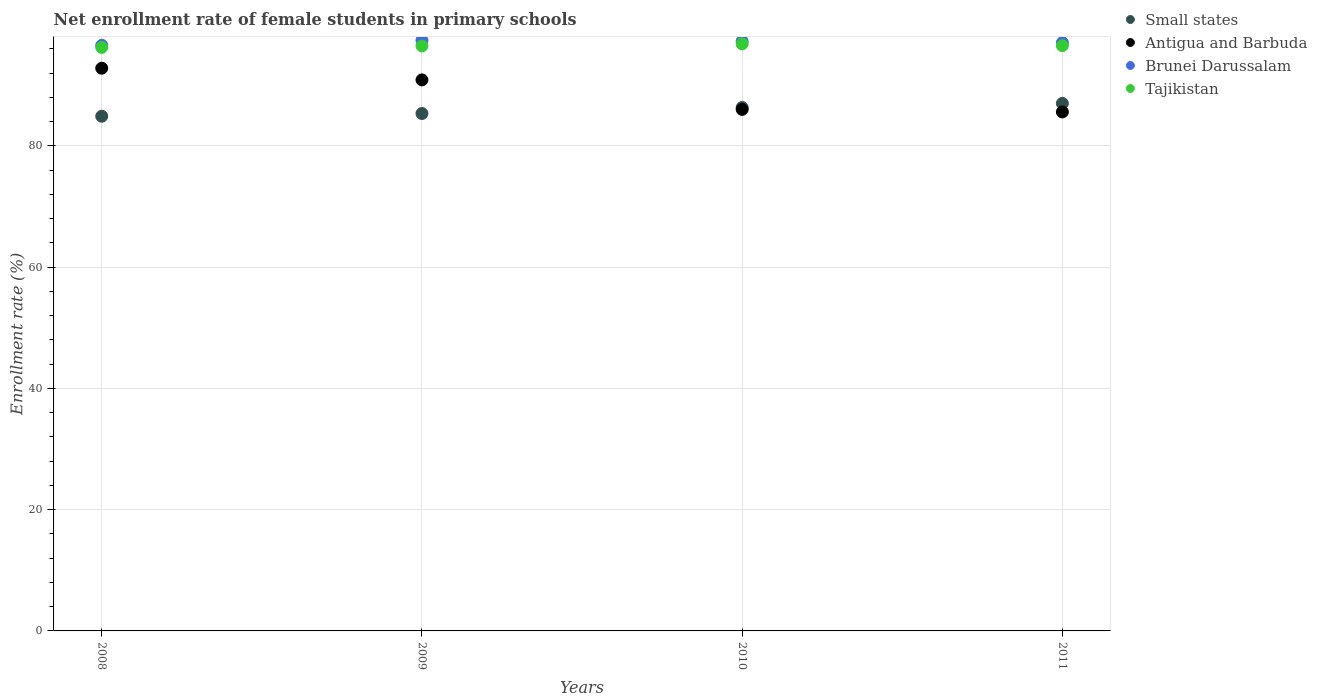How many different coloured dotlines are there?
Your answer should be compact. 4. Is the number of dotlines equal to the number of legend labels?
Offer a very short reply. Yes. What is the net enrollment rate of female students in primary schools in Brunei Darussalam in 2010?
Keep it short and to the point. 97.24. Across all years, what is the maximum net enrollment rate of female students in primary schools in Antigua and Barbuda?
Provide a succinct answer. 92.81. Across all years, what is the minimum net enrollment rate of female students in primary schools in Brunei Darussalam?
Your answer should be compact. 96.58. In which year was the net enrollment rate of female students in primary schools in Small states minimum?
Your answer should be compact. 2008. What is the total net enrollment rate of female students in primary schools in Small states in the graph?
Your answer should be very brief. 343.55. What is the difference between the net enrollment rate of female students in primary schools in Small states in 2009 and that in 2011?
Offer a very short reply. -1.67. What is the difference between the net enrollment rate of female students in primary schools in Brunei Darussalam in 2011 and the net enrollment rate of female students in primary schools in Antigua and Barbuda in 2010?
Ensure brevity in your answer.  11.01. What is the average net enrollment rate of female students in primary schools in Tajikistan per year?
Provide a succinct answer. 96.51. In the year 2008, what is the difference between the net enrollment rate of female students in primary schools in Brunei Darussalam and net enrollment rate of female students in primary schools in Tajikistan?
Your answer should be compact. 0.34. In how many years, is the net enrollment rate of female students in primary schools in Brunei Darussalam greater than 12 %?
Make the answer very short. 4. What is the ratio of the net enrollment rate of female students in primary schools in Brunei Darussalam in 2008 to that in 2011?
Offer a terse response. 1. What is the difference between the highest and the second highest net enrollment rate of female students in primary schools in Antigua and Barbuda?
Provide a short and direct response. 1.93. What is the difference between the highest and the lowest net enrollment rate of female students in primary schools in Brunei Darussalam?
Offer a terse response. 0.82. In how many years, is the net enrollment rate of female students in primary schools in Brunei Darussalam greater than the average net enrollment rate of female students in primary schools in Brunei Darussalam taken over all years?
Keep it short and to the point. 2. Is the sum of the net enrollment rate of female students in primary schools in Tajikistan in 2010 and 2011 greater than the maximum net enrollment rate of female students in primary schools in Brunei Darussalam across all years?
Your answer should be very brief. Yes. Is it the case that in every year, the sum of the net enrollment rate of female students in primary schools in Small states and net enrollment rate of female students in primary schools in Tajikistan  is greater than the sum of net enrollment rate of female students in primary schools in Brunei Darussalam and net enrollment rate of female students in primary schools in Antigua and Barbuda?
Ensure brevity in your answer.  No. Is the net enrollment rate of female students in primary schools in Small states strictly greater than the net enrollment rate of female students in primary schools in Brunei Darussalam over the years?
Your answer should be compact. No. How many dotlines are there?
Your answer should be compact. 4. How many years are there in the graph?
Keep it short and to the point. 4. What is the difference between two consecutive major ticks on the Y-axis?
Provide a short and direct response. 20. Does the graph contain any zero values?
Provide a succinct answer. No. What is the title of the graph?
Your answer should be compact. Net enrollment rate of female students in primary schools. Does "Venezuela" appear as one of the legend labels in the graph?
Make the answer very short. No. What is the label or title of the X-axis?
Keep it short and to the point. Years. What is the label or title of the Y-axis?
Your response must be concise. Enrollment rate (%). What is the Enrollment rate (%) in Small states in 2008?
Your answer should be very brief. 84.89. What is the Enrollment rate (%) in Antigua and Barbuda in 2008?
Keep it short and to the point. 92.81. What is the Enrollment rate (%) of Brunei Darussalam in 2008?
Your answer should be very brief. 96.58. What is the Enrollment rate (%) of Tajikistan in 2008?
Provide a succinct answer. 96.24. What is the Enrollment rate (%) of Small states in 2009?
Ensure brevity in your answer.  85.34. What is the Enrollment rate (%) in Antigua and Barbuda in 2009?
Provide a short and direct response. 90.88. What is the Enrollment rate (%) of Brunei Darussalam in 2009?
Offer a very short reply. 97.4. What is the Enrollment rate (%) of Tajikistan in 2009?
Provide a succinct answer. 96.47. What is the Enrollment rate (%) in Small states in 2010?
Ensure brevity in your answer.  86.33. What is the Enrollment rate (%) of Antigua and Barbuda in 2010?
Ensure brevity in your answer.  86.01. What is the Enrollment rate (%) of Brunei Darussalam in 2010?
Offer a terse response. 97.24. What is the Enrollment rate (%) of Tajikistan in 2010?
Offer a very short reply. 96.82. What is the Enrollment rate (%) in Small states in 2011?
Your answer should be very brief. 87. What is the Enrollment rate (%) in Antigua and Barbuda in 2011?
Your answer should be very brief. 85.59. What is the Enrollment rate (%) in Brunei Darussalam in 2011?
Ensure brevity in your answer.  97.02. What is the Enrollment rate (%) in Tajikistan in 2011?
Keep it short and to the point. 96.52. Across all years, what is the maximum Enrollment rate (%) of Small states?
Your response must be concise. 87. Across all years, what is the maximum Enrollment rate (%) in Antigua and Barbuda?
Keep it short and to the point. 92.81. Across all years, what is the maximum Enrollment rate (%) in Brunei Darussalam?
Provide a short and direct response. 97.4. Across all years, what is the maximum Enrollment rate (%) of Tajikistan?
Provide a succinct answer. 96.82. Across all years, what is the minimum Enrollment rate (%) of Small states?
Your answer should be compact. 84.89. Across all years, what is the minimum Enrollment rate (%) in Antigua and Barbuda?
Ensure brevity in your answer.  85.59. Across all years, what is the minimum Enrollment rate (%) of Brunei Darussalam?
Offer a very short reply. 96.58. Across all years, what is the minimum Enrollment rate (%) of Tajikistan?
Your answer should be compact. 96.24. What is the total Enrollment rate (%) of Small states in the graph?
Your answer should be very brief. 343.55. What is the total Enrollment rate (%) of Antigua and Barbuda in the graph?
Provide a succinct answer. 355.29. What is the total Enrollment rate (%) of Brunei Darussalam in the graph?
Your response must be concise. 388.23. What is the total Enrollment rate (%) of Tajikistan in the graph?
Offer a terse response. 386.05. What is the difference between the Enrollment rate (%) of Small states in 2008 and that in 2009?
Your response must be concise. -0.45. What is the difference between the Enrollment rate (%) of Antigua and Barbuda in 2008 and that in 2009?
Keep it short and to the point. 1.93. What is the difference between the Enrollment rate (%) in Brunei Darussalam in 2008 and that in 2009?
Give a very brief answer. -0.82. What is the difference between the Enrollment rate (%) in Tajikistan in 2008 and that in 2009?
Your answer should be very brief. -0.24. What is the difference between the Enrollment rate (%) in Small states in 2008 and that in 2010?
Your answer should be very brief. -1.44. What is the difference between the Enrollment rate (%) of Antigua and Barbuda in 2008 and that in 2010?
Your answer should be very brief. 6.79. What is the difference between the Enrollment rate (%) in Brunei Darussalam in 2008 and that in 2010?
Make the answer very short. -0.66. What is the difference between the Enrollment rate (%) in Tajikistan in 2008 and that in 2010?
Ensure brevity in your answer.  -0.58. What is the difference between the Enrollment rate (%) of Small states in 2008 and that in 2011?
Offer a very short reply. -2.12. What is the difference between the Enrollment rate (%) of Antigua and Barbuda in 2008 and that in 2011?
Your answer should be compact. 7.21. What is the difference between the Enrollment rate (%) of Brunei Darussalam in 2008 and that in 2011?
Offer a very short reply. -0.44. What is the difference between the Enrollment rate (%) of Tajikistan in 2008 and that in 2011?
Your response must be concise. -0.29. What is the difference between the Enrollment rate (%) of Small states in 2009 and that in 2010?
Make the answer very short. -0.99. What is the difference between the Enrollment rate (%) of Antigua and Barbuda in 2009 and that in 2010?
Your answer should be compact. 4.87. What is the difference between the Enrollment rate (%) in Brunei Darussalam in 2009 and that in 2010?
Provide a succinct answer. 0.16. What is the difference between the Enrollment rate (%) in Tajikistan in 2009 and that in 2010?
Your answer should be very brief. -0.35. What is the difference between the Enrollment rate (%) of Small states in 2009 and that in 2011?
Keep it short and to the point. -1.67. What is the difference between the Enrollment rate (%) of Antigua and Barbuda in 2009 and that in 2011?
Give a very brief answer. 5.29. What is the difference between the Enrollment rate (%) in Brunei Darussalam in 2009 and that in 2011?
Ensure brevity in your answer.  0.38. What is the difference between the Enrollment rate (%) in Tajikistan in 2009 and that in 2011?
Provide a succinct answer. -0.05. What is the difference between the Enrollment rate (%) in Small states in 2010 and that in 2011?
Your answer should be compact. -0.68. What is the difference between the Enrollment rate (%) in Antigua and Barbuda in 2010 and that in 2011?
Make the answer very short. 0.42. What is the difference between the Enrollment rate (%) in Brunei Darussalam in 2010 and that in 2011?
Your answer should be compact. 0.21. What is the difference between the Enrollment rate (%) in Tajikistan in 2010 and that in 2011?
Provide a succinct answer. 0.3. What is the difference between the Enrollment rate (%) of Small states in 2008 and the Enrollment rate (%) of Antigua and Barbuda in 2009?
Offer a very short reply. -5.99. What is the difference between the Enrollment rate (%) of Small states in 2008 and the Enrollment rate (%) of Brunei Darussalam in 2009?
Make the answer very short. -12.51. What is the difference between the Enrollment rate (%) of Small states in 2008 and the Enrollment rate (%) of Tajikistan in 2009?
Give a very brief answer. -11.59. What is the difference between the Enrollment rate (%) in Antigua and Barbuda in 2008 and the Enrollment rate (%) in Brunei Darussalam in 2009?
Your response must be concise. -4.59. What is the difference between the Enrollment rate (%) in Antigua and Barbuda in 2008 and the Enrollment rate (%) in Tajikistan in 2009?
Give a very brief answer. -3.67. What is the difference between the Enrollment rate (%) in Brunei Darussalam in 2008 and the Enrollment rate (%) in Tajikistan in 2009?
Give a very brief answer. 0.11. What is the difference between the Enrollment rate (%) in Small states in 2008 and the Enrollment rate (%) in Antigua and Barbuda in 2010?
Your answer should be very brief. -1.13. What is the difference between the Enrollment rate (%) of Small states in 2008 and the Enrollment rate (%) of Brunei Darussalam in 2010?
Give a very brief answer. -12.35. What is the difference between the Enrollment rate (%) of Small states in 2008 and the Enrollment rate (%) of Tajikistan in 2010?
Ensure brevity in your answer.  -11.94. What is the difference between the Enrollment rate (%) in Antigua and Barbuda in 2008 and the Enrollment rate (%) in Brunei Darussalam in 2010?
Offer a terse response. -4.43. What is the difference between the Enrollment rate (%) in Antigua and Barbuda in 2008 and the Enrollment rate (%) in Tajikistan in 2010?
Your answer should be very brief. -4.01. What is the difference between the Enrollment rate (%) of Brunei Darussalam in 2008 and the Enrollment rate (%) of Tajikistan in 2010?
Provide a succinct answer. -0.24. What is the difference between the Enrollment rate (%) in Small states in 2008 and the Enrollment rate (%) in Antigua and Barbuda in 2011?
Offer a very short reply. -0.71. What is the difference between the Enrollment rate (%) in Small states in 2008 and the Enrollment rate (%) in Brunei Darussalam in 2011?
Your answer should be very brief. -12.14. What is the difference between the Enrollment rate (%) in Small states in 2008 and the Enrollment rate (%) in Tajikistan in 2011?
Provide a short and direct response. -11.64. What is the difference between the Enrollment rate (%) of Antigua and Barbuda in 2008 and the Enrollment rate (%) of Brunei Darussalam in 2011?
Keep it short and to the point. -4.22. What is the difference between the Enrollment rate (%) in Antigua and Barbuda in 2008 and the Enrollment rate (%) in Tajikistan in 2011?
Make the answer very short. -3.72. What is the difference between the Enrollment rate (%) of Brunei Darussalam in 2008 and the Enrollment rate (%) of Tajikistan in 2011?
Keep it short and to the point. 0.05. What is the difference between the Enrollment rate (%) of Small states in 2009 and the Enrollment rate (%) of Antigua and Barbuda in 2010?
Provide a succinct answer. -0.68. What is the difference between the Enrollment rate (%) of Small states in 2009 and the Enrollment rate (%) of Brunei Darussalam in 2010?
Offer a very short reply. -11.9. What is the difference between the Enrollment rate (%) of Small states in 2009 and the Enrollment rate (%) of Tajikistan in 2010?
Your answer should be compact. -11.48. What is the difference between the Enrollment rate (%) in Antigua and Barbuda in 2009 and the Enrollment rate (%) in Brunei Darussalam in 2010?
Offer a very short reply. -6.36. What is the difference between the Enrollment rate (%) of Antigua and Barbuda in 2009 and the Enrollment rate (%) of Tajikistan in 2010?
Ensure brevity in your answer.  -5.94. What is the difference between the Enrollment rate (%) in Brunei Darussalam in 2009 and the Enrollment rate (%) in Tajikistan in 2010?
Your answer should be very brief. 0.58. What is the difference between the Enrollment rate (%) of Small states in 2009 and the Enrollment rate (%) of Antigua and Barbuda in 2011?
Offer a very short reply. -0.25. What is the difference between the Enrollment rate (%) of Small states in 2009 and the Enrollment rate (%) of Brunei Darussalam in 2011?
Ensure brevity in your answer.  -11.68. What is the difference between the Enrollment rate (%) of Small states in 2009 and the Enrollment rate (%) of Tajikistan in 2011?
Offer a very short reply. -11.19. What is the difference between the Enrollment rate (%) of Antigua and Barbuda in 2009 and the Enrollment rate (%) of Brunei Darussalam in 2011?
Make the answer very short. -6.14. What is the difference between the Enrollment rate (%) in Antigua and Barbuda in 2009 and the Enrollment rate (%) in Tajikistan in 2011?
Offer a very short reply. -5.64. What is the difference between the Enrollment rate (%) of Brunei Darussalam in 2009 and the Enrollment rate (%) of Tajikistan in 2011?
Provide a short and direct response. 0.87. What is the difference between the Enrollment rate (%) in Small states in 2010 and the Enrollment rate (%) in Antigua and Barbuda in 2011?
Offer a very short reply. 0.74. What is the difference between the Enrollment rate (%) in Small states in 2010 and the Enrollment rate (%) in Brunei Darussalam in 2011?
Offer a very short reply. -10.69. What is the difference between the Enrollment rate (%) of Small states in 2010 and the Enrollment rate (%) of Tajikistan in 2011?
Make the answer very short. -10.2. What is the difference between the Enrollment rate (%) in Antigua and Barbuda in 2010 and the Enrollment rate (%) in Brunei Darussalam in 2011?
Keep it short and to the point. -11.01. What is the difference between the Enrollment rate (%) of Antigua and Barbuda in 2010 and the Enrollment rate (%) of Tajikistan in 2011?
Your answer should be compact. -10.51. What is the difference between the Enrollment rate (%) of Brunei Darussalam in 2010 and the Enrollment rate (%) of Tajikistan in 2011?
Ensure brevity in your answer.  0.71. What is the average Enrollment rate (%) in Small states per year?
Keep it short and to the point. 85.89. What is the average Enrollment rate (%) of Antigua and Barbuda per year?
Your answer should be compact. 88.82. What is the average Enrollment rate (%) in Brunei Darussalam per year?
Make the answer very short. 97.06. What is the average Enrollment rate (%) in Tajikistan per year?
Your answer should be very brief. 96.51. In the year 2008, what is the difference between the Enrollment rate (%) in Small states and Enrollment rate (%) in Antigua and Barbuda?
Ensure brevity in your answer.  -7.92. In the year 2008, what is the difference between the Enrollment rate (%) of Small states and Enrollment rate (%) of Brunei Darussalam?
Provide a short and direct response. -11.69. In the year 2008, what is the difference between the Enrollment rate (%) in Small states and Enrollment rate (%) in Tajikistan?
Offer a terse response. -11.35. In the year 2008, what is the difference between the Enrollment rate (%) in Antigua and Barbuda and Enrollment rate (%) in Brunei Darussalam?
Your answer should be very brief. -3.77. In the year 2008, what is the difference between the Enrollment rate (%) of Antigua and Barbuda and Enrollment rate (%) of Tajikistan?
Your answer should be compact. -3.43. In the year 2008, what is the difference between the Enrollment rate (%) in Brunei Darussalam and Enrollment rate (%) in Tajikistan?
Your answer should be compact. 0.34. In the year 2009, what is the difference between the Enrollment rate (%) of Small states and Enrollment rate (%) of Antigua and Barbuda?
Offer a very short reply. -5.54. In the year 2009, what is the difference between the Enrollment rate (%) in Small states and Enrollment rate (%) in Brunei Darussalam?
Ensure brevity in your answer.  -12.06. In the year 2009, what is the difference between the Enrollment rate (%) of Small states and Enrollment rate (%) of Tajikistan?
Offer a terse response. -11.14. In the year 2009, what is the difference between the Enrollment rate (%) in Antigua and Barbuda and Enrollment rate (%) in Brunei Darussalam?
Your answer should be very brief. -6.52. In the year 2009, what is the difference between the Enrollment rate (%) of Antigua and Barbuda and Enrollment rate (%) of Tajikistan?
Give a very brief answer. -5.59. In the year 2009, what is the difference between the Enrollment rate (%) of Brunei Darussalam and Enrollment rate (%) of Tajikistan?
Give a very brief answer. 0.92. In the year 2010, what is the difference between the Enrollment rate (%) in Small states and Enrollment rate (%) in Antigua and Barbuda?
Offer a very short reply. 0.31. In the year 2010, what is the difference between the Enrollment rate (%) in Small states and Enrollment rate (%) in Brunei Darussalam?
Make the answer very short. -10.91. In the year 2010, what is the difference between the Enrollment rate (%) of Small states and Enrollment rate (%) of Tajikistan?
Provide a short and direct response. -10.49. In the year 2010, what is the difference between the Enrollment rate (%) of Antigua and Barbuda and Enrollment rate (%) of Brunei Darussalam?
Provide a succinct answer. -11.22. In the year 2010, what is the difference between the Enrollment rate (%) in Antigua and Barbuda and Enrollment rate (%) in Tajikistan?
Keep it short and to the point. -10.81. In the year 2010, what is the difference between the Enrollment rate (%) in Brunei Darussalam and Enrollment rate (%) in Tajikistan?
Offer a terse response. 0.42. In the year 2011, what is the difference between the Enrollment rate (%) in Small states and Enrollment rate (%) in Antigua and Barbuda?
Make the answer very short. 1.41. In the year 2011, what is the difference between the Enrollment rate (%) of Small states and Enrollment rate (%) of Brunei Darussalam?
Your response must be concise. -10.02. In the year 2011, what is the difference between the Enrollment rate (%) of Small states and Enrollment rate (%) of Tajikistan?
Offer a terse response. -9.52. In the year 2011, what is the difference between the Enrollment rate (%) of Antigua and Barbuda and Enrollment rate (%) of Brunei Darussalam?
Make the answer very short. -11.43. In the year 2011, what is the difference between the Enrollment rate (%) in Antigua and Barbuda and Enrollment rate (%) in Tajikistan?
Your answer should be very brief. -10.93. In the year 2011, what is the difference between the Enrollment rate (%) in Brunei Darussalam and Enrollment rate (%) in Tajikistan?
Make the answer very short. 0.5. What is the ratio of the Enrollment rate (%) of Antigua and Barbuda in 2008 to that in 2009?
Provide a succinct answer. 1.02. What is the ratio of the Enrollment rate (%) in Brunei Darussalam in 2008 to that in 2009?
Offer a very short reply. 0.99. What is the ratio of the Enrollment rate (%) in Tajikistan in 2008 to that in 2009?
Offer a terse response. 1. What is the ratio of the Enrollment rate (%) in Small states in 2008 to that in 2010?
Offer a very short reply. 0.98. What is the ratio of the Enrollment rate (%) in Antigua and Barbuda in 2008 to that in 2010?
Your answer should be very brief. 1.08. What is the ratio of the Enrollment rate (%) of Brunei Darussalam in 2008 to that in 2010?
Ensure brevity in your answer.  0.99. What is the ratio of the Enrollment rate (%) of Small states in 2008 to that in 2011?
Your response must be concise. 0.98. What is the ratio of the Enrollment rate (%) of Antigua and Barbuda in 2008 to that in 2011?
Offer a very short reply. 1.08. What is the ratio of the Enrollment rate (%) in Tajikistan in 2008 to that in 2011?
Make the answer very short. 1. What is the ratio of the Enrollment rate (%) in Antigua and Barbuda in 2009 to that in 2010?
Make the answer very short. 1.06. What is the ratio of the Enrollment rate (%) in Small states in 2009 to that in 2011?
Provide a short and direct response. 0.98. What is the ratio of the Enrollment rate (%) in Antigua and Barbuda in 2009 to that in 2011?
Ensure brevity in your answer.  1.06. What is the ratio of the Enrollment rate (%) in Antigua and Barbuda in 2010 to that in 2011?
Offer a very short reply. 1. What is the ratio of the Enrollment rate (%) in Tajikistan in 2010 to that in 2011?
Give a very brief answer. 1. What is the difference between the highest and the second highest Enrollment rate (%) of Small states?
Make the answer very short. 0.68. What is the difference between the highest and the second highest Enrollment rate (%) in Antigua and Barbuda?
Your answer should be compact. 1.93. What is the difference between the highest and the second highest Enrollment rate (%) in Brunei Darussalam?
Offer a very short reply. 0.16. What is the difference between the highest and the second highest Enrollment rate (%) of Tajikistan?
Keep it short and to the point. 0.3. What is the difference between the highest and the lowest Enrollment rate (%) of Small states?
Your answer should be compact. 2.12. What is the difference between the highest and the lowest Enrollment rate (%) of Antigua and Barbuda?
Your answer should be compact. 7.21. What is the difference between the highest and the lowest Enrollment rate (%) in Brunei Darussalam?
Your answer should be compact. 0.82. What is the difference between the highest and the lowest Enrollment rate (%) in Tajikistan?
Ensure brevity in your answer.  0.58. 